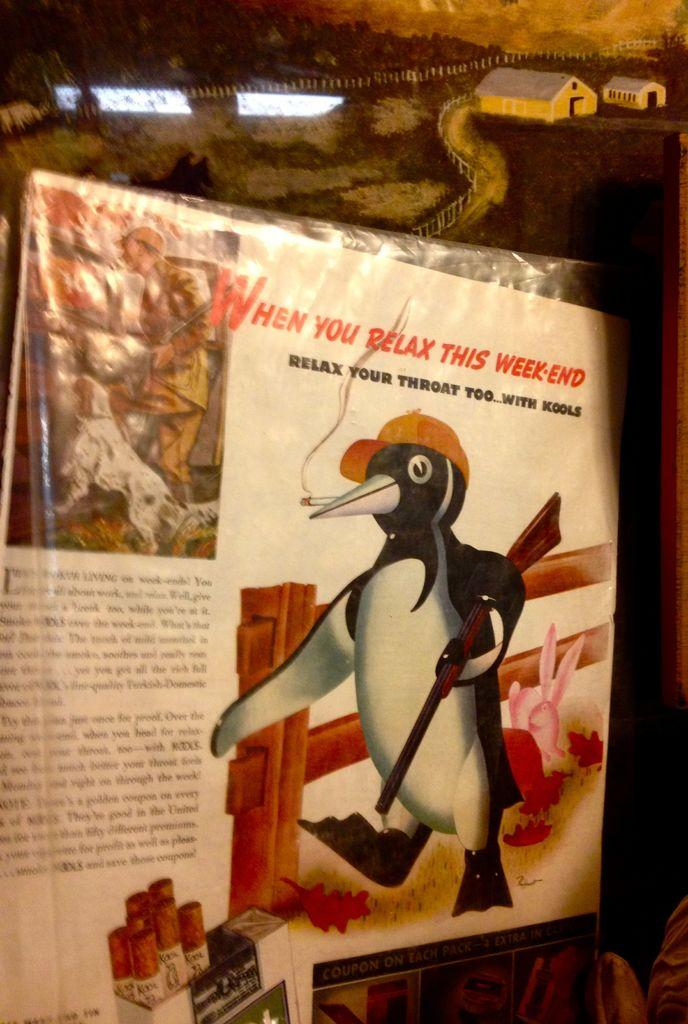What is the main subject of the drawing in the image? There is a drawing of a penguin in the center of the image. What can be seen in the background of the drawing? There is a sketch of buildings in the background, along with fencing, grass, and trees. How much tax is the penguin paying in the image? There is no mention of tax or any financial aspect in the image, as it is a drawing of a penguin and its background. 